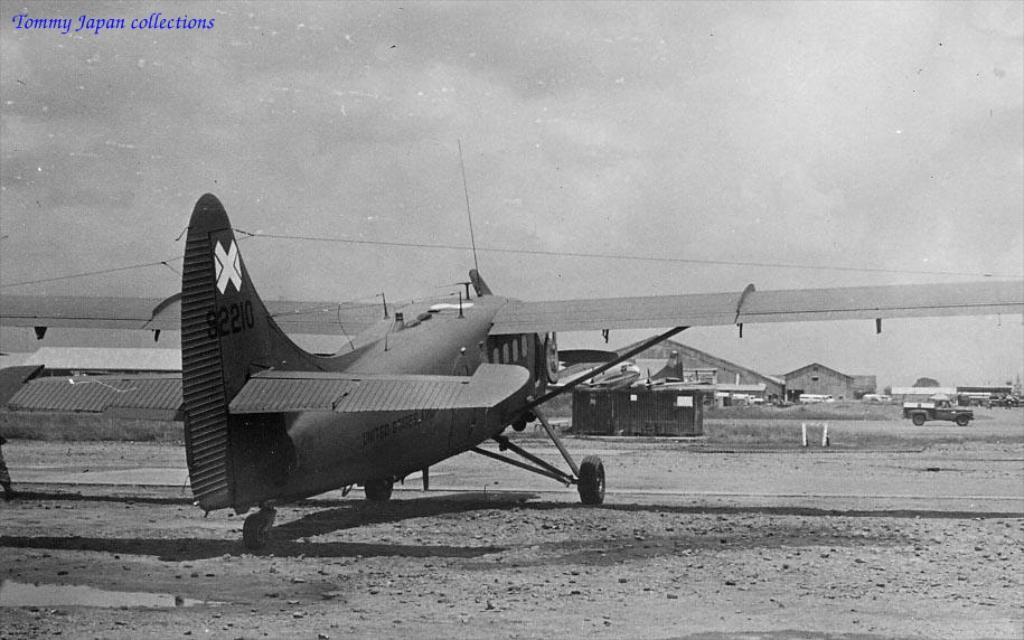What type of aircraft is present in the image? There is a helicopter in the image. What other types of vehicles can be seen in the image? There are other vehicles in the image, but their specific types are not mentioned. What is the rate of juice consumption in the image? There is no mention of juice or its consumption in the image. 